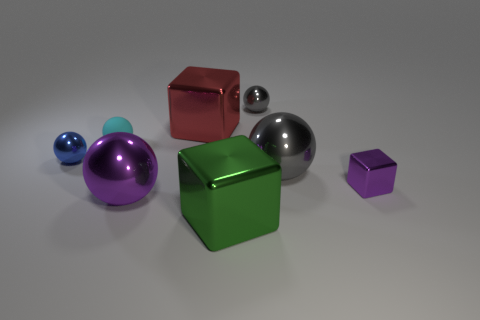Subtract all brown cubes. How many gray spheres are left? 2 Subtract all large metal balls. How many balls are left? 3 Subtract all cyan spheres. How many spheres are left? 4 Add 2 metallic cylinders. How many objects exist? 10 Subtract all purple balls. Subtract all gray cubes. How many balls are left? 4 Subtract all balls. How many objects are left? 3 Add 6 matte objects. How many matte objects exist? 7 Subtract 0 cyan blocks. How many objects are left? 8 Subtract all blue balls. Subtract all big green cubes. How many objects are left? 6 Add 2 large metallic balls. How many large metallic balls are left? 4 